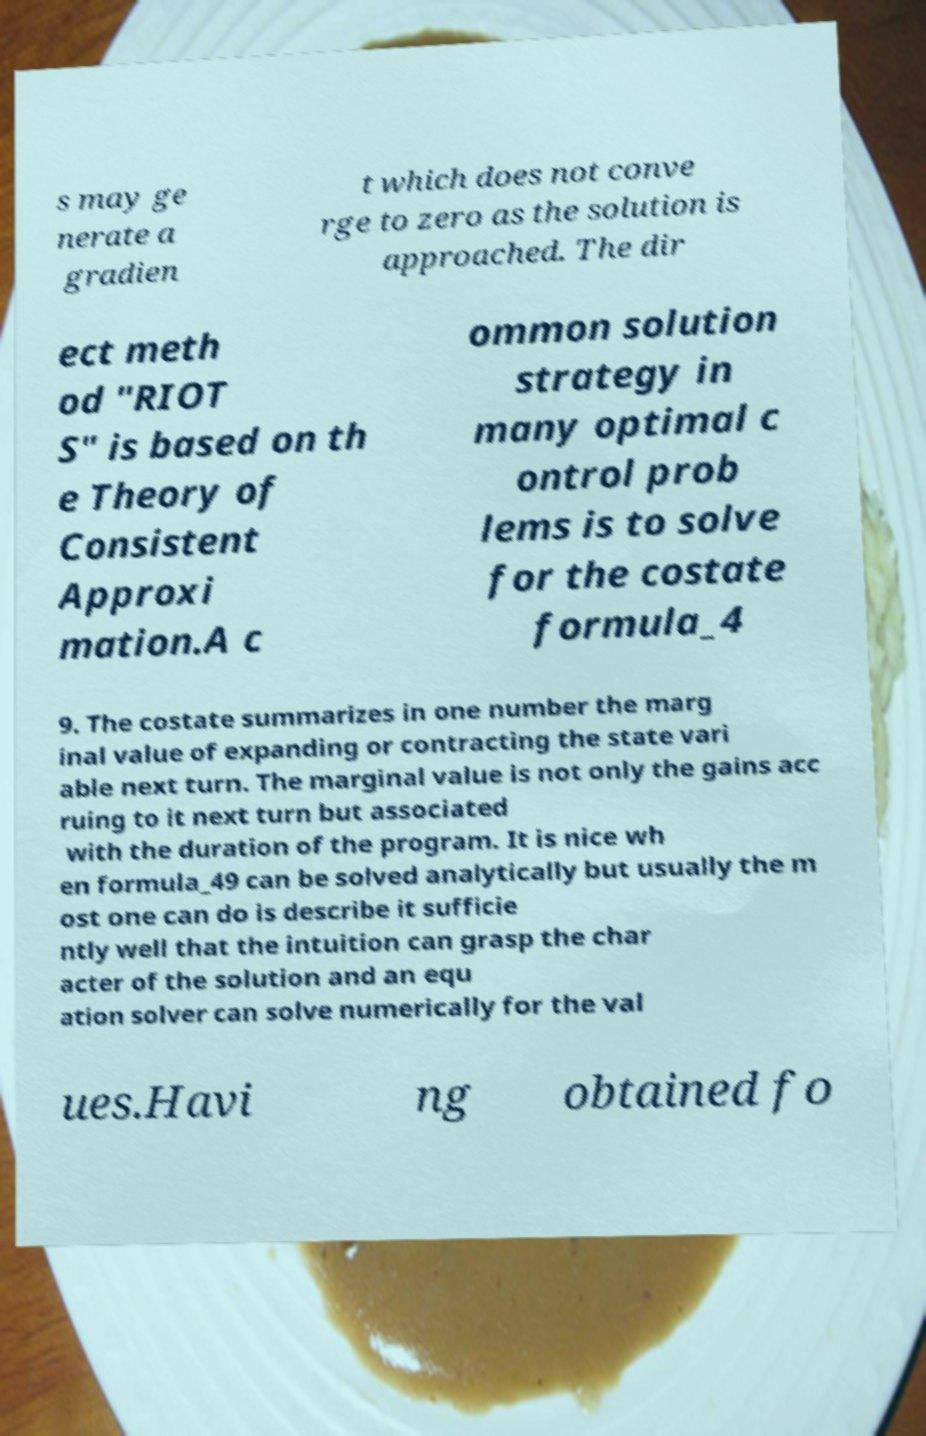Please identify and transcribe the text found in this image. s may ge nerate a gradien t which does not conve rge to zero as the solution is approached. The dir ect meth od "RIOT S" is based on th e Theory of Consistent Approxi mation.A c ommon solution strategy in many optimal c ontrol prob lems is to solve for the costate formula_4 9. The costate summarizes in one number the marg inal value of expanding or contracting the state vari able next turn. The marginal value is not only the gains acc ruing to it next turn but associated with the duration of the program. It is nice wh en formula_49 can be solved analytically but usually the m ost one can do is describe it sufficie ntly well that the intuition can grasp the char acter of the solution and an equ ation solver can solve numerically for the val ues.Havi ng obtained fo 